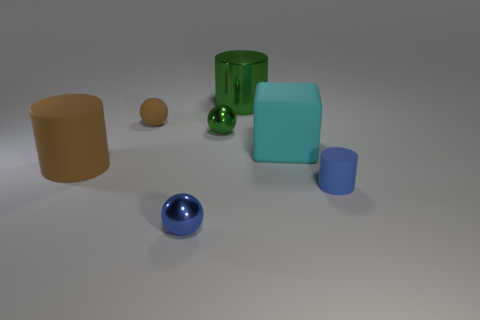What materials are the objects in this image potentially made of? The objects appear to be rendered with various materials. The matte block may represent a kind of frosted glass or plastic due to its opacity and light scattering properties. The shiny spheres could be metal or glass, given their reflective quality. The cylinder and smaller cube seem to be of a matte surface, possibly made of clay or a matte painted wood. 